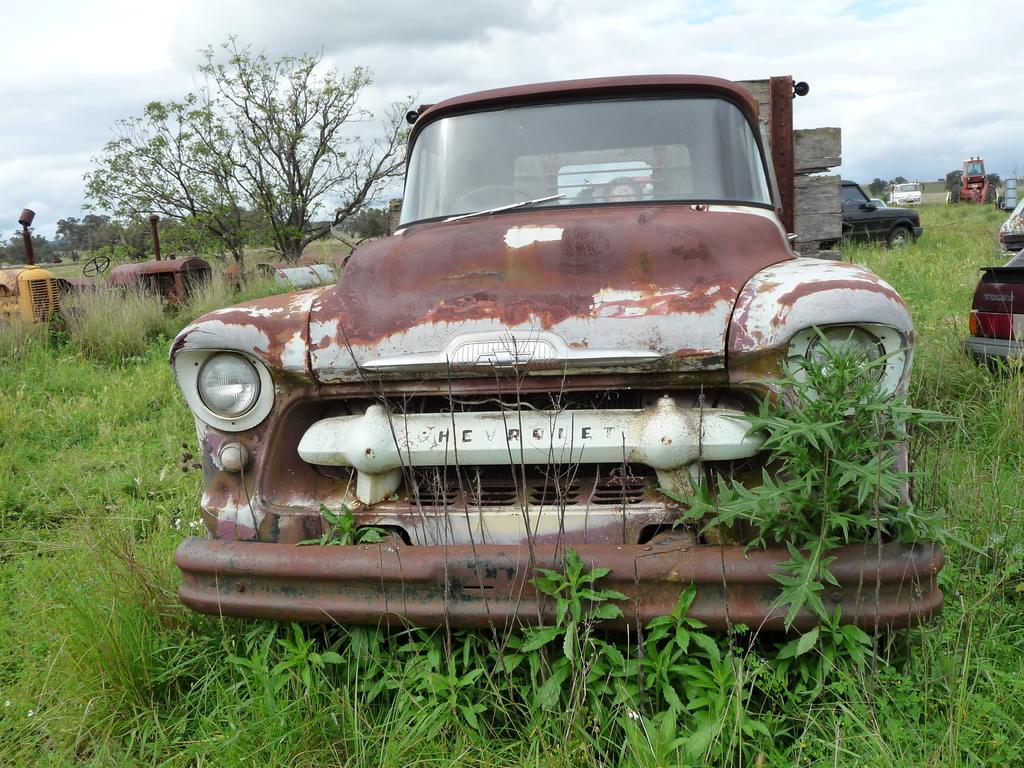What type of terrain is visible in the image? There is an open grass ground in the image. What else can be seen on the grass ground? There are vehicles on the grass ground. What can be seen in the distance in the image? There are trees in the background of the image. What is visible in the sky in the image? There are clouds in the sky, and the sky is visible in the background of the image. How does the grass ground twist in the image? The grass ground does not twist in the image; it is a flat terrain. 